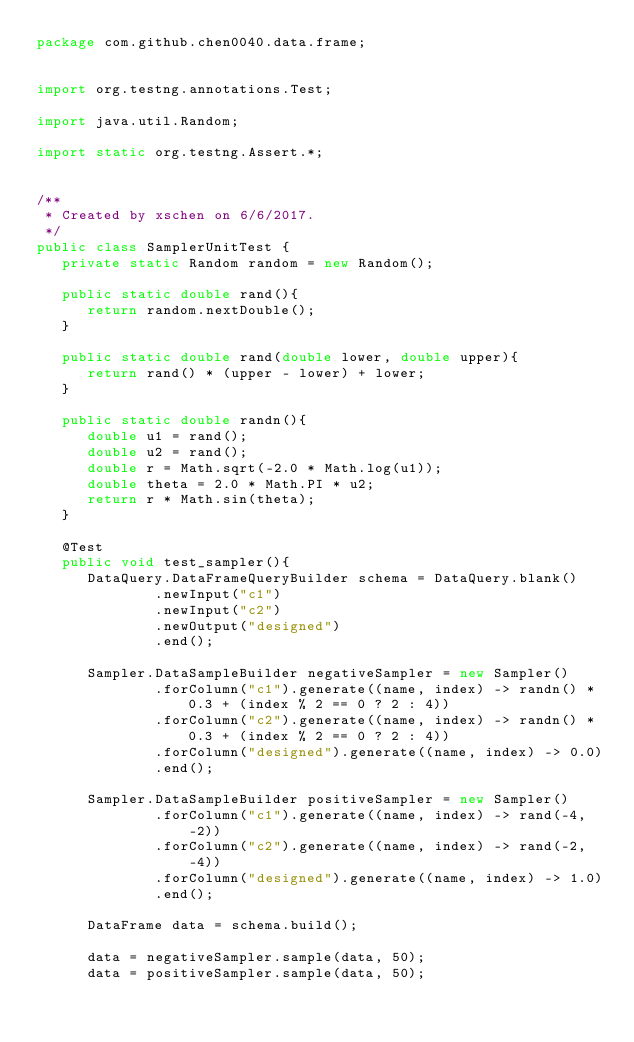<code> <loc_0><loc_0><loc_500><loc_500><_Java_>package com.github.chen0040.data.frame;


import org.testng.annotations.Test;

import java.util.Random;

import static org.testng.Assert.*;


/**
 * Created by xschen on 6/6/2017.
 */
public class SamplerUnitTest {
   private static Random random = new Random();

   public static double rand(){
      return random.nextDouble();
   }

   public static double rand(double lower, double upper){
      return rand() * (upper - lower) + lower;
   }

   public static double randn(){
      double u1 = rand();
      double u2 = rand();
      double r = Math.sqrt(-2.0 * Math.log(u1));
      double theta = 2.0 * Math.PI * u2;
      return r * Math.sin(theta);
   }

   @Test
   public void test_sampler(){
      DataQuery.DataFrameQueryBuilder schema = DataQuery.blank()
              .newInput("c1")
              .newInput("c2")
              .newOutput("designed")
              .end();

      Sampler.DataSampleBuilder negativeSampler = new Sampler()
              .forColumn("c1").generate((name, index) -> randn() * 0.3 + (index % 2 == 0 ? 2 : 4))
              .forColumn("c2").generate((name, index) -> randn() * 0.3 + (index % 2 == 0 ? 2 : 4))
              .forColumn("designed").generate((name, index) -> 0.0)
              .end();

      Sampler.DataSampleBuilder positiveSampler = new Sampler()
              .forColumn("c1").generate((name, index) -> rand(-4, -2))
              .forColumn("c2").generate((name, index) -> rand(-2, -4))
              .forColumn("designed").generate((name, index) -> 1.0)
              .end();

      DataFrame data = schema.build();

      data = negativeSampler.sample(data, 50);
      data = positiveSampler.sample(data, 50);
</code> 